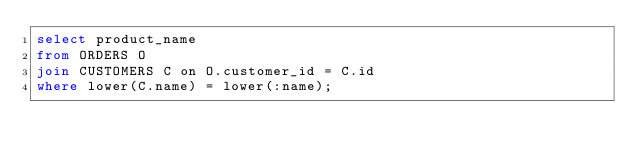<code> <loc_0><loc_0><loc_500><loc_500><_SQL_>select product_name
from ORDERS O
join CUSTOMERS C on O.customer_id = C.id
where lower(C.name) = lower(:name);</code> 